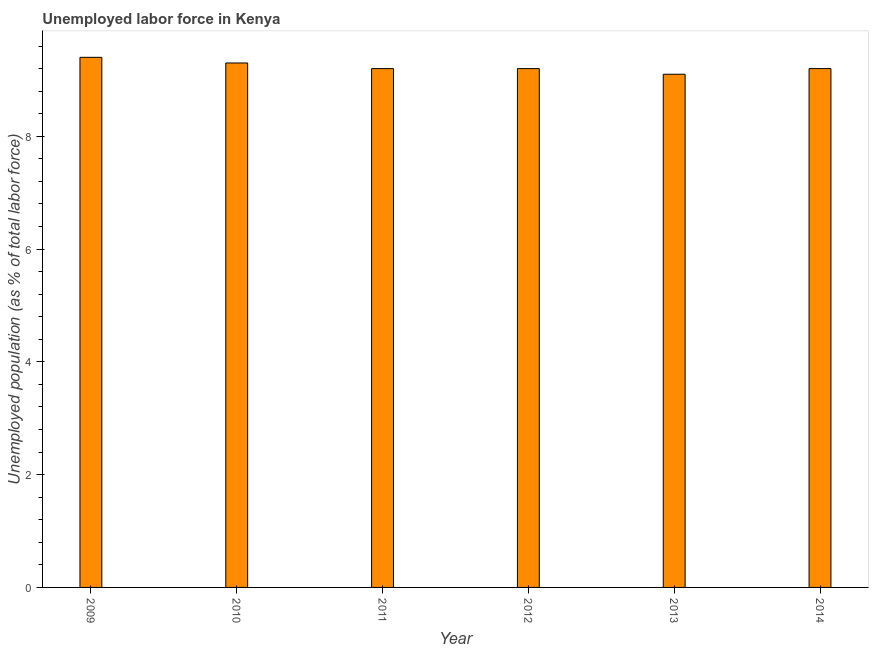Does the graph contain any zero values?
Your response must be concise. No. What is the title of the graph?
Give a very brief answer. Unemployed labor force in Kenya. What is the label or title of the X-axis?
Your answer should be very brief. Year. What is the label or title of the Y-axis?
Offer a terse response. Unemployed population (as % of total labor force). What is the total unemployed population in 2009?
Your answer should be very brief. 9.4. Across all years, what is the maximum total unemployed population?
Provide a short and direct response. 9.4. Across all years, what is the minimum total unemployed population?
Your answer should be very brief. 9.1. What is the sum of the total unemployed population?
Give a very brief answer. 55.4. What is the difference between the total unemployed population in 2013 and 2014?
Keep it short and to the point. -0.1. What is the average total unemployed population per year?
Give a very brief answer. 9.23. What is the median total unemployed population?
Your answer should be very brief. 9.2. In how many years, is the total unemployed population greater than 7.2 %?
Ensure brevity in your answer.  6. Do a majority of the years between 2009 and 2012 (inclusive) have total unemployed population greater than 8 %?
Keep it short and to the point. Yes. What is the ratio of the total unemployed population in 2010 to that in 2011?
Offer a very short reply. 1.01. Is the total unemployed population in 2010 less than that in 2014?
Offer a terse response. No. Is the sum of the total unemployed population in 2011 and 2012 greater than the maximum total unemployed population across all years?
Your answer should be compact. Yes. In how many years, is the total unemployed population greater than the average total unemployed population taken over all years?
Offer a terse response. 2. What is the difference between two consecutive major ticks on the Y-axis?
Offer a very short reply. 2. What is the Unemployed population (as % of total labor force) of 2009?
Your answer should be very brief. 9.4. What is the Unemployed population (as % of total labor force) of 2010?
Your response must be concise. 9.3. What is the Unemployed population (as % of total labor force) of 2011?
Your answer should be compact. 9.2. What is the Unemployed population (as % of total labor force) in 2012?
Your answer should be very brief. 9.2. What is the Unemployed population (as % of total labor force) of 2013?
Offer a very short reply. 9.1. What is the Unemployed population (as % of total labor force) of 2014?
Give a very brief answer. 9.2. What is the difference between the Unemployed population (as % of total labor force) in 2009 and 2011?
Keep it short and to the point. 0.2. What is the difference between the Unemployed population (as % of total labor force) in 2009 and 2012?
Make the answer very short. 0.2. What is the difference between the Unemployed population (as % of total labor force) in 2010 and 2012?
Provide a succinct answer. 0.1. What is the difference between the Unemployed population (as % of total labor force) in 2010 and 2013?
Make the answer very short. 0.2. What is the difference between the Unemployed population (as % of total labor force) in 2011 and 2012?
Offer a terse response. 0. What is the difference between the Unemployed population (as % of total labor force) in 2011 and 2014?
Your answer should be compact. 0. What is the difference between the Unemployed population (as % of total labor force) in 2012 and 2013?
Your response must be concise. 0.1. What is the difference between the Unemployed population (as % of total labor force) in 2012 and 2014?
Ensure brevity in your answer.  0. What is the difference between the Unemployed population (as % of total labor force) in 2013 and 2014?
Ensure brevity in your answer.  -0.1. What is the ratio of the Unemployed population (as % of total labor force) in 2009 to that in 2010?
Your answer should be compact. 1.01. What is the ratio of the Unemployed population (as % of total labor force) in 2009 to that in 2013?
Your answer should be very brief. 1.03. What is the ratio of the Unemployed population (as % of total labor force) in 2009 to that in 2014?
Your answer should be compact. 1.02. What is the ratio of the Unemployed population (as % of total labor force) in 2010 to that in 2011?
Make the answer very short. 1.01. What is the ratio of the Unemployed population (as % of total labor force) in 2010 to that in 2013?
Offer a terse response. 1.02. What is the ratio of the Unemployed population (as % of total labor force) in 2010 to that in 2014?
Make the answer very short. 1.01. What is the ratio of the Unemployed population (as % of total labor force) in 2011 to that in 2013?
Make the answer very short. 1.01. What is the ratio of the Unemployed population (as % of total labor force) in 2011 to that in 2014?
Ensure brevity in your answer.  1. What is the ratio of the Unemployed population (as % of total labor force) in 2012 to that in 2013?
Ensure brevity in your answer.  1.01. What is the ratio of the Unemployed population (as % of total labor force) in 2012 to that in 2014?
Make the answer very short. 1. What is the ratio of the Unemployed population (as % of total labor force) in 2013 to that in 2014?
Provide a succinct answer. 0.99. 